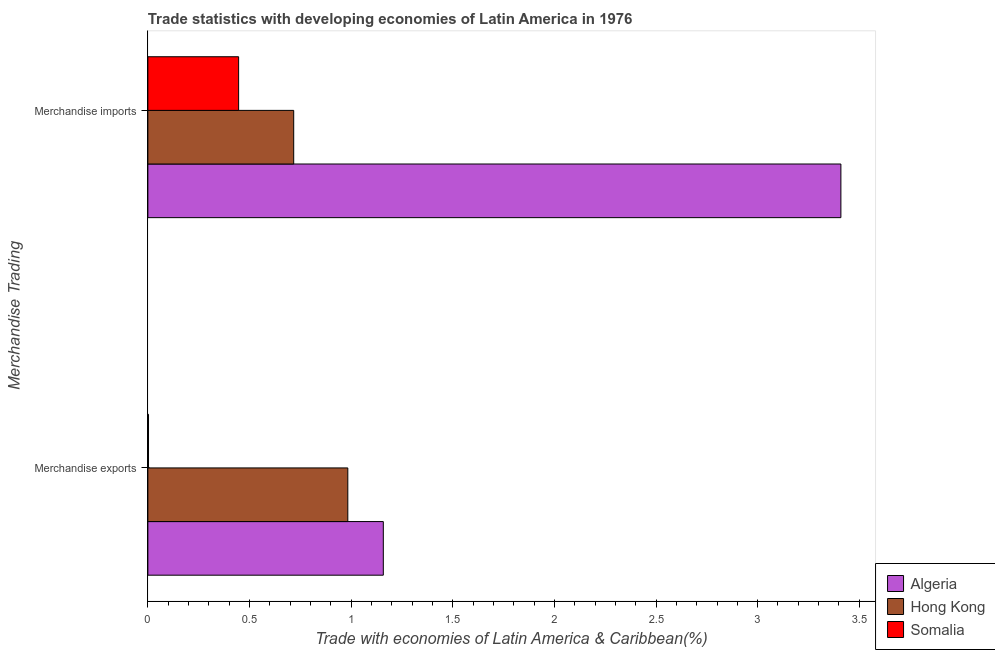How many bars are there on the 2nd tick from the bottom?
Your answer should be compact. 3. What is the merchandise exports in Somalia?
Offer a very short reply. 0. Across all countries, what is the maximum merchandise imports?
Provide a succinct answer. 3.41. Across all countries, what is the minimum merchandise imports?
Make the answer very short. 0.45. In which country was the merchandise imports maximum?
Offer a very short reply. Algeria. In which country was the merchandise imports minimum?
Offer a terse response. Somalia. What is the total merchandise imports in the graph?
Offer a terse response. 4.57. What is the difference between the merchandise imports in Hong Kong and that in Algeria?
Give a very brief answer. -2.69. What is the difference between the merchandise exports in Hong Kong and the merchandise imports in Algeria?
Give a very brief answer. -2.43. What is the average merchandise exports per country?
Your answer should be very brief. 0.72. What is the difference between the merchandise imports and merchandise exports in Somalia?
Provide a short and direct response. 0.44. In how many countries, is the merchandise exports greater than 1.2 %?
Ensure brevity in your answer.  0. What is the ratio of the merchandise imports in Somalia to that in Algeria?
Give a very brief answer. 0.13. Is the merchandise exports in Algeria less than that in Hong Kong?
Keep it short and to the point. No. In how many countries, is the merchandise imports greater than the average merchandise imports taken over all countries?
Offer a terse response. 1. What does the 1st bar from the top in Merchandise exports represents?
Provide a succinct answer. Somalia. What does the 3rd bar from the bottom in Merchandise imports represents?
Ensure brevity in your answer.  Somalia. How many bars are there?
Offer a terse response. 6. Are all the bars in the graph horizontal?
Provide a short and direct response. Yes. How many countries are there in the graph?
Ensure brevity in your answer.  3. What is the difference between two consecutive major ticks on the X-axis?
Keep it short and to the point. 0.5. Are the values on the major ticks of X-axis written in scientific E-notation?
Your response must be concise. No. Does the graph contain any zero values?
Keep it short and to the point. No. What is the title of the graph?
Ensure brevity in your answer.  Trade statistics with developing economies of Latin America in 1976. What is the label or title of the X-axis?
Offer a terse response. Trade with economies of Latin America & Caribbean(%). What is the label or title of the Y-axis?
Your response must be concise. Merchandise Trading. What is the Trade with economies of Latin America & Caribbean(%) of Algeria in Merchandise exports?
Ensure brevity in your answer.  1.16. What is the Trade with economies of Latin America & Caribbean(%) in Hong Kong in Merchandise exports?
Make the answer very short. 0.98. What is the Trade with economies of Latin America & Caribbean(%) in Somalia in Merchandise exports?
Provide a succinct answer. 0. What is the Trade with economies of Latin America & Caribbean(%) in Algeria in Merchandise imports?
Keep it short and to the point. 3.41. What is the Trade with economies of Latin America & Caribbean(%) of Hong Kong in Merchandise imports?
Your answer should be very brief. 0.72. What is the Trade with economies of Latin America & Caribbean(%) in Somalia in Merchandise imports?
Your response must be concise. 0.45. Across all Merchandise Trading, what is the maximum Trade with economies of Latin America & Caribbean(%) in Algeria?
Keep it short and to the point. 3.41. Across all Merchandise Trading, what is the maximum Trade with economies of Latin America & Caribbean(%) in Hong Kong?
Your response must be concise. 0.98. Across all Merchandise Trading, what is the maximum Trade with economies of Latin America & Caribbean(%) in Somalia?
Give a very brief answer. 0.45. Across all Merchandise Trading, what is the minimum Trade with economies of Latin America & Caribbean(%) in Algeria?
Make the answer very short. 1.16. Across all Merchandise Trading, what is the minimum Trade with economies of Latin America & Caribbean(%) in Hong Kong?
Make the answer very short. 0.72. Across all Merchandise Trading, what is the minimum Trade with economies of Latin America & Caribbean(%) in Somalia?
Provide a short and direct response. 0. What is the total Trade with economies of Latin America & Caribbean(%) of Algeria in the graph?
Make the answer very short. 4.57. What is the total Trade with economies of Latin America & Caribbean(%) in Hong Kong in the graph?
Provide a short and direct response. 1.7. What is the total Trade with economies of Latin America & Caribbean(%) of Somalia in the graph?
Provide a short and direct response. 0.45. What is the difference between the Trade with economies of Latin America & Caribbean(%) of Algeria in Merchandise exports and that in Merchandise imports?
Ensure brevity in your answer.  -2.25. What is the difference between the Trade with economies of Latin America & Caribbean(%) of Hong Kong in Merchandise exports and that in Merchandise imports?
Offer a very short reply. 0.27. What is the difference between the Trade with economies of Latin America & Caribbean(%) in Somalia in Merchandise exports and that in Merchandise imports?
Make the answer very short. -0.44. What is the difference between the Trade with economies of Latin America & Caribbean(%) of Algeria in Merchandise exports and the Trade with economies of Latin America & Caribbean(%) of Hong Kong in Merchandise imports?
Ensure brevity in your answer.  0.44. What is the difference between the Trade with economies of Latin America & Caribbean(%) in Algeria in Merchandise exports and the Trade with economies of Latin America & Caribbean(%) in Somalia in Merchandise imports?
Ensure brevity in your answer.  0.71. What is the difference between the Trade with economies of Latin America & Caribbean(%) of Hong Kong in Merchandise exports and the Trade with economies of Latin America & Caribbean(%) of Somalia in Merchandise imports?
Provide a succinct answer. 0.54. What is the average Trade with economies of Latin America & Caribbean(%) in Algeria per Merchandise Trading?
Your response must be concise. 2.28. What is the average Trade with economies of Latin America & Caribbean(%) in Hong Kong per Merchandise Trading?
Your response must be concise. 0.85. What is the average Trade with economies of Latin America & Caribbean(%) of Somalia per Merchandise Trading?
Provide a succinct answer. 0.22. What is the difference between the Trade with economies of Latin America & Caribbean(%) of Algeria and Trade with economies of Latin America & Caribbean(%) of Hong Kong in Merchandise exports?
Provide a succinct answer. 0.17. What is the difference between the Trade with economies of Latin America & Caribbean(%) in Algeria and Trade with economies of Latin America & Caribbean(%) in Somalia in Merchandise exports?
Your answer should be very brief. 1.16. What is the difference between the Trade with economies of Latin America & Caribbean(%) of Hong Kong and Trade with economies of Latin America & Caribbean(%) of Somalia in Merchandise exports?
Ensure brevity in your answer.  0.98. What is the difference between the Trade with economies of Latin America & Caribbean(%) in Algeria and Trade with economies of Latin America & Caribbean(%) in Hong Kong in Merchandise imports?
Your answer should be compact. 2.69. What is the difference between the Trade with economies of Latin America & Caribbean(%) of Algeria and Trade with economies of Latin America & Caribbean(%) of Somalia in Merchandise imports?
Provide a short and direct response. 2.96. What is the difference between the Trade with economies of Latin America & Caribbean(%) in Hong Kong and Trade with economies of Latin America & Caribbean(%) in Somalia in Merchandise imports?
Provide a succinct answer. 0.27. What is the ratio of the Trade with economies of Latin America & Caribbean(%) in Algeria in Merchandise exports to that in Merchandise imports?
Your answer should be compact. 0.34. What is the ratio of the Trade with economies of Latin America & Caribbean(%) of Hong Kong in Merchandise exports to that in Merchandise imports?
Provide a succinct answer. 1.37. What is the ratio of the Trade with economies of Latin America & Caribbean(%) of Somalia in Merchandise exports to that in Merchandise imports?
Your answer should be very brief. 0.01. What is the difference between the highest and the second highest Trade with economies of Latin America & Caribbean(%) in Algeria?
Make the answer very short. 2.25. What is the difference between the highest and the second highest Trade with economies of Latin America & Caribbean(%) in Hong Kong?
Make the answer very short. 0.27. What is the difference between the highest and the second highest Trade with economies of Latin America & Caribbean(%) in Somalia?
Your answer should be compact. 0.44. What is the difference between the highest and the lowest Trade with economies of Latin America & Caribbean(%) in Algeria?
Offer a terse response. 2.25. What is the difference between the highest and the lowest Trade with economies of Latin America & Caribbean(%) of Hong Kong?
Your answer should be compact. 0.27. What is the difference between the highest and the lowest Trade with economies of Latin America & Caribbean(%) of Somalia?
Your answer should be very brief. 0.44. 